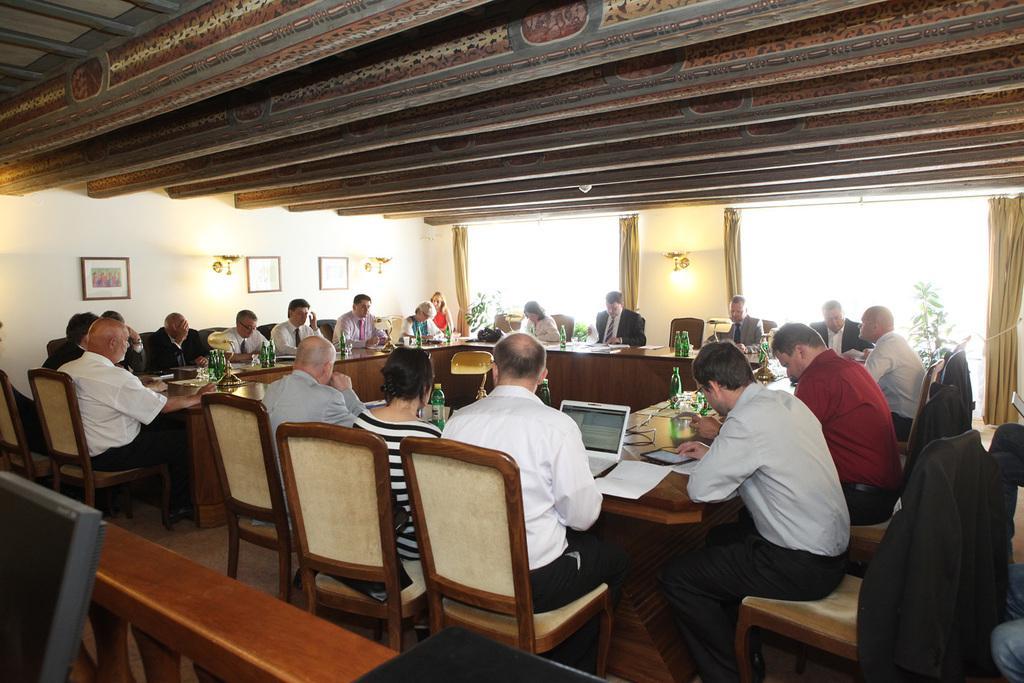Could you give a brief overview of what you see in this image? In this image there are group of people sitting in chairs and on table there are laptops, bottles, glasses, papers ,and at back ground there are frames, lamps attached to wall , curtains, windows. 